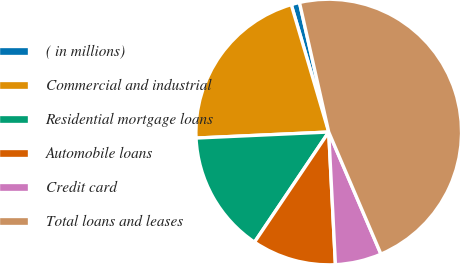Convert chart to OTSL. <chart><loc_0><loc_0><loc_500><loc_500><pie_chart><fcel>( in millions)<fcel>Commercial and industrial<fcel>Residential mortgage loans<fcel>Automobile loans<fcel>Credit card<fcel>Total loans and leases<nl><fcel>1.02%<fcel>21.17%<fcel>14.84%<fcel>10.24%<fcel>5.63%<fcel>47.1%<nl></chart> 